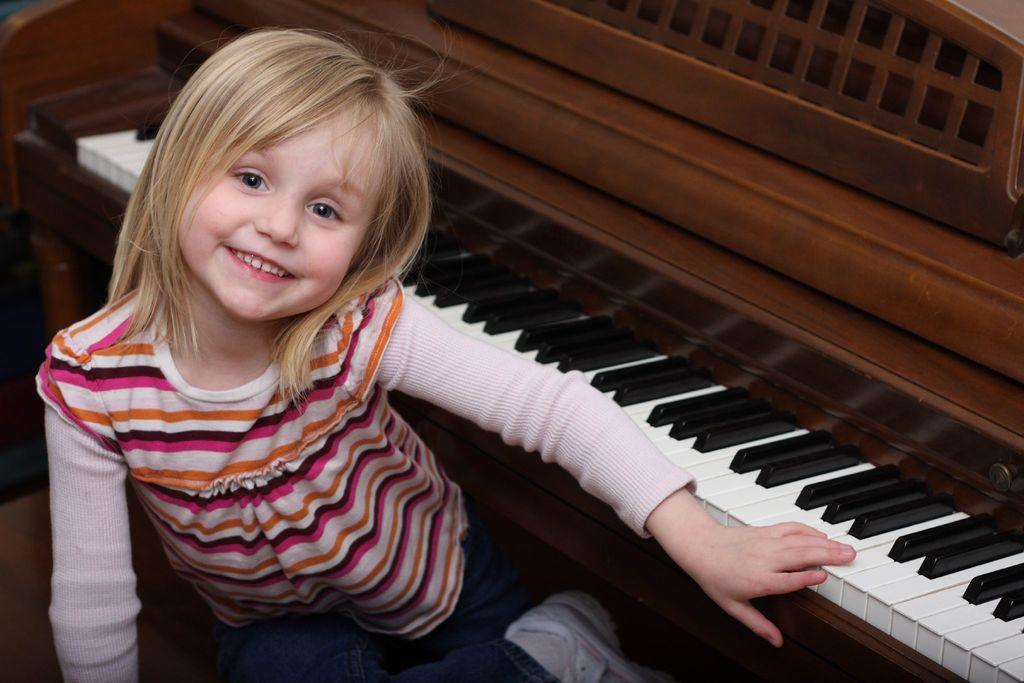Who is the main subject in the image? There is a girl in the image. What is the girl doing in the image? The girl is sitting. What is the girl's facial expression in the image? The girl is smiling. What object is beside the girl in the image? There is a piano beside the girl. What can be observed about the piano's keys? The piano has black and white keys. How does the girl use humor to roll the piano in the image? The girl does not use humor to roll the piano in the image, as there is no indication of her rolling the piano, and the image does not show any humor. 